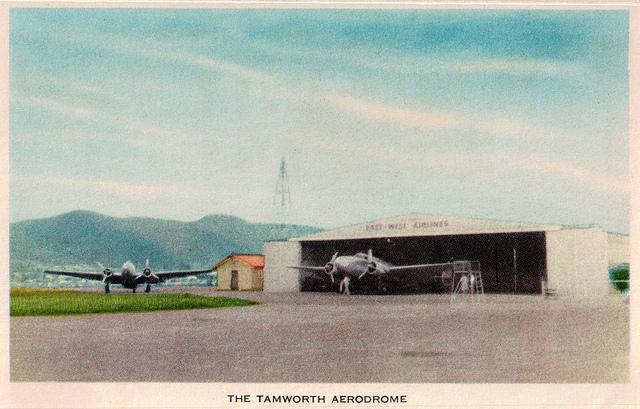Where is the silver plane on the right being stored? hanger 